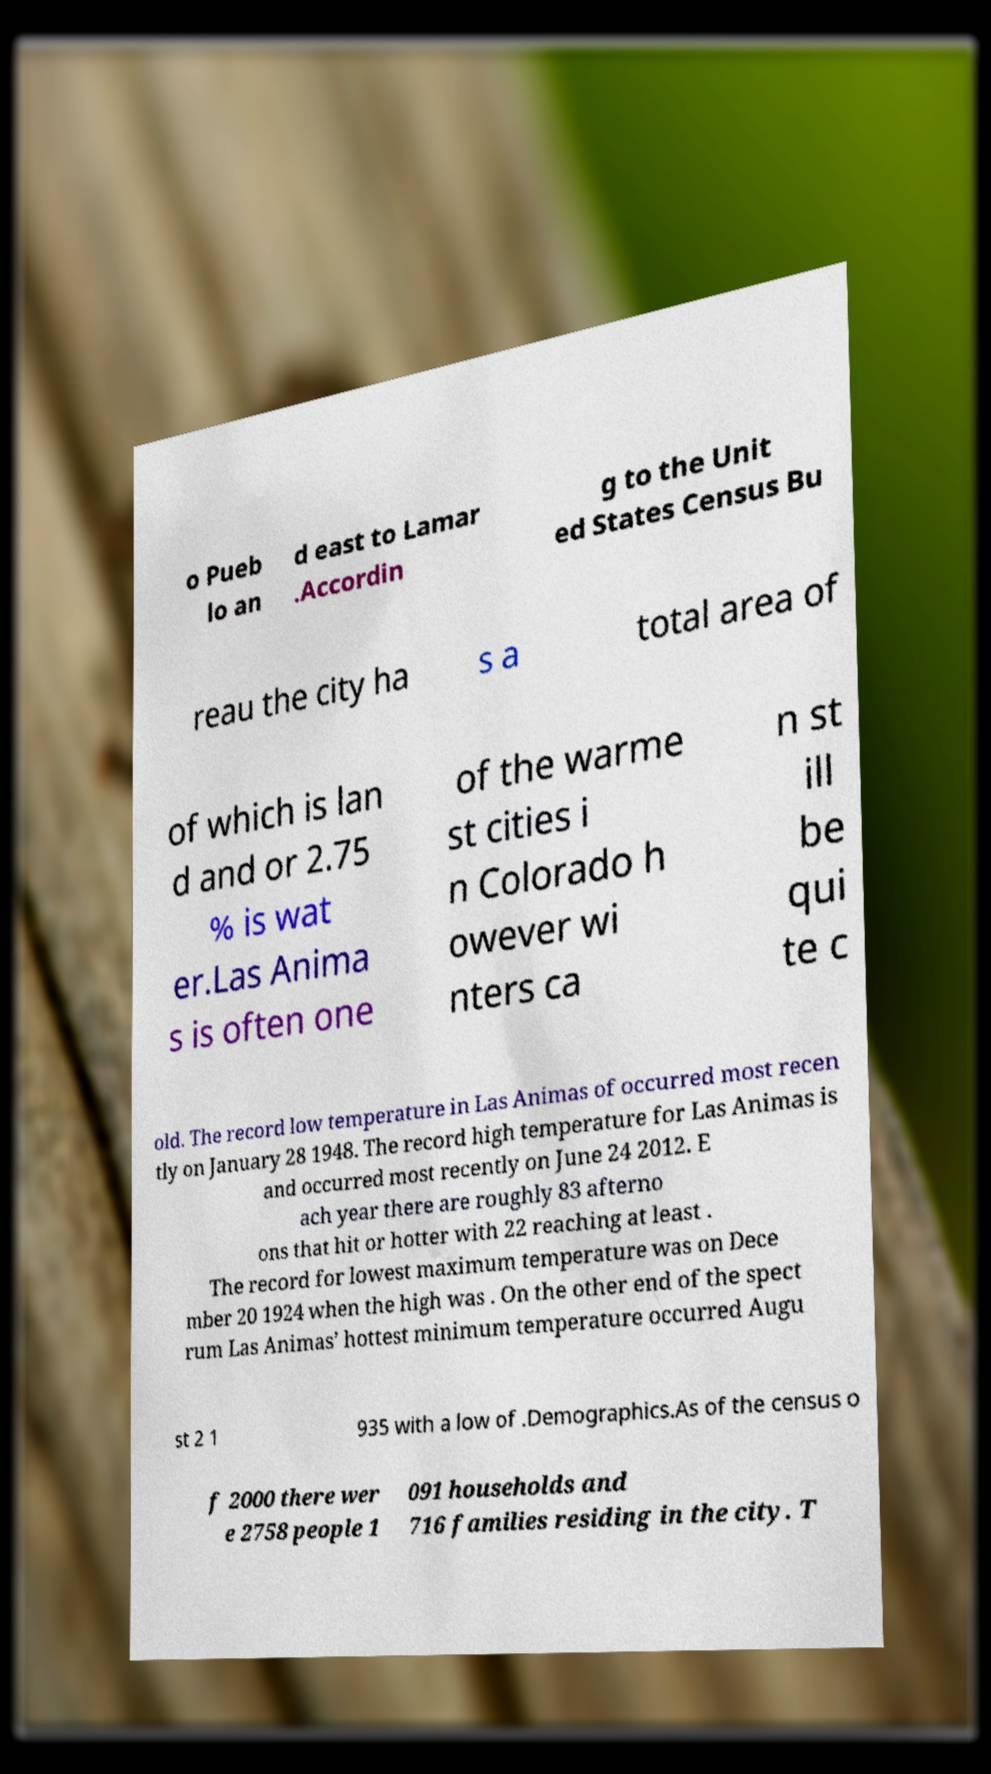Could you extract and type out the text from this image? o Pueb lo an d east to Lamar .Accordin g to the Unit ed States Census Bu reau the city ha s a total area of of which is lan d and or 2.75 % is wat er.Las Anima s is often one of the warme st cities i n Colorado h owever wi nters ca n st ill be qui te c old. The record low temperature in Las Animas of occurred most recen tly on January 28 1948. The record high temperature for Las Animas is and occurred most recently on June 24 2012. E ach year there are roughly 83 afterno ons that hit or hotter with 22 reaching at least . The record for lowest maximum temperature was on Dece mber 20 1924 when the high was . On the other end of the spect rum Las Animas’ hottest minimum temperature occurred Augu st 2 1 935 with a low of .Demographics.As of the census o f 2000 there wer e 2758 people 1 091 households and 716 families residing in the city. T 